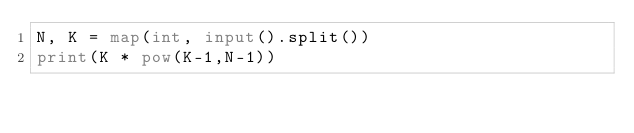<code> <loc_0><loc_0><loc_500><loc_500><_Python_>N, K = map(int, input().split())
print(K * pow(K-1,N-1))</code> 